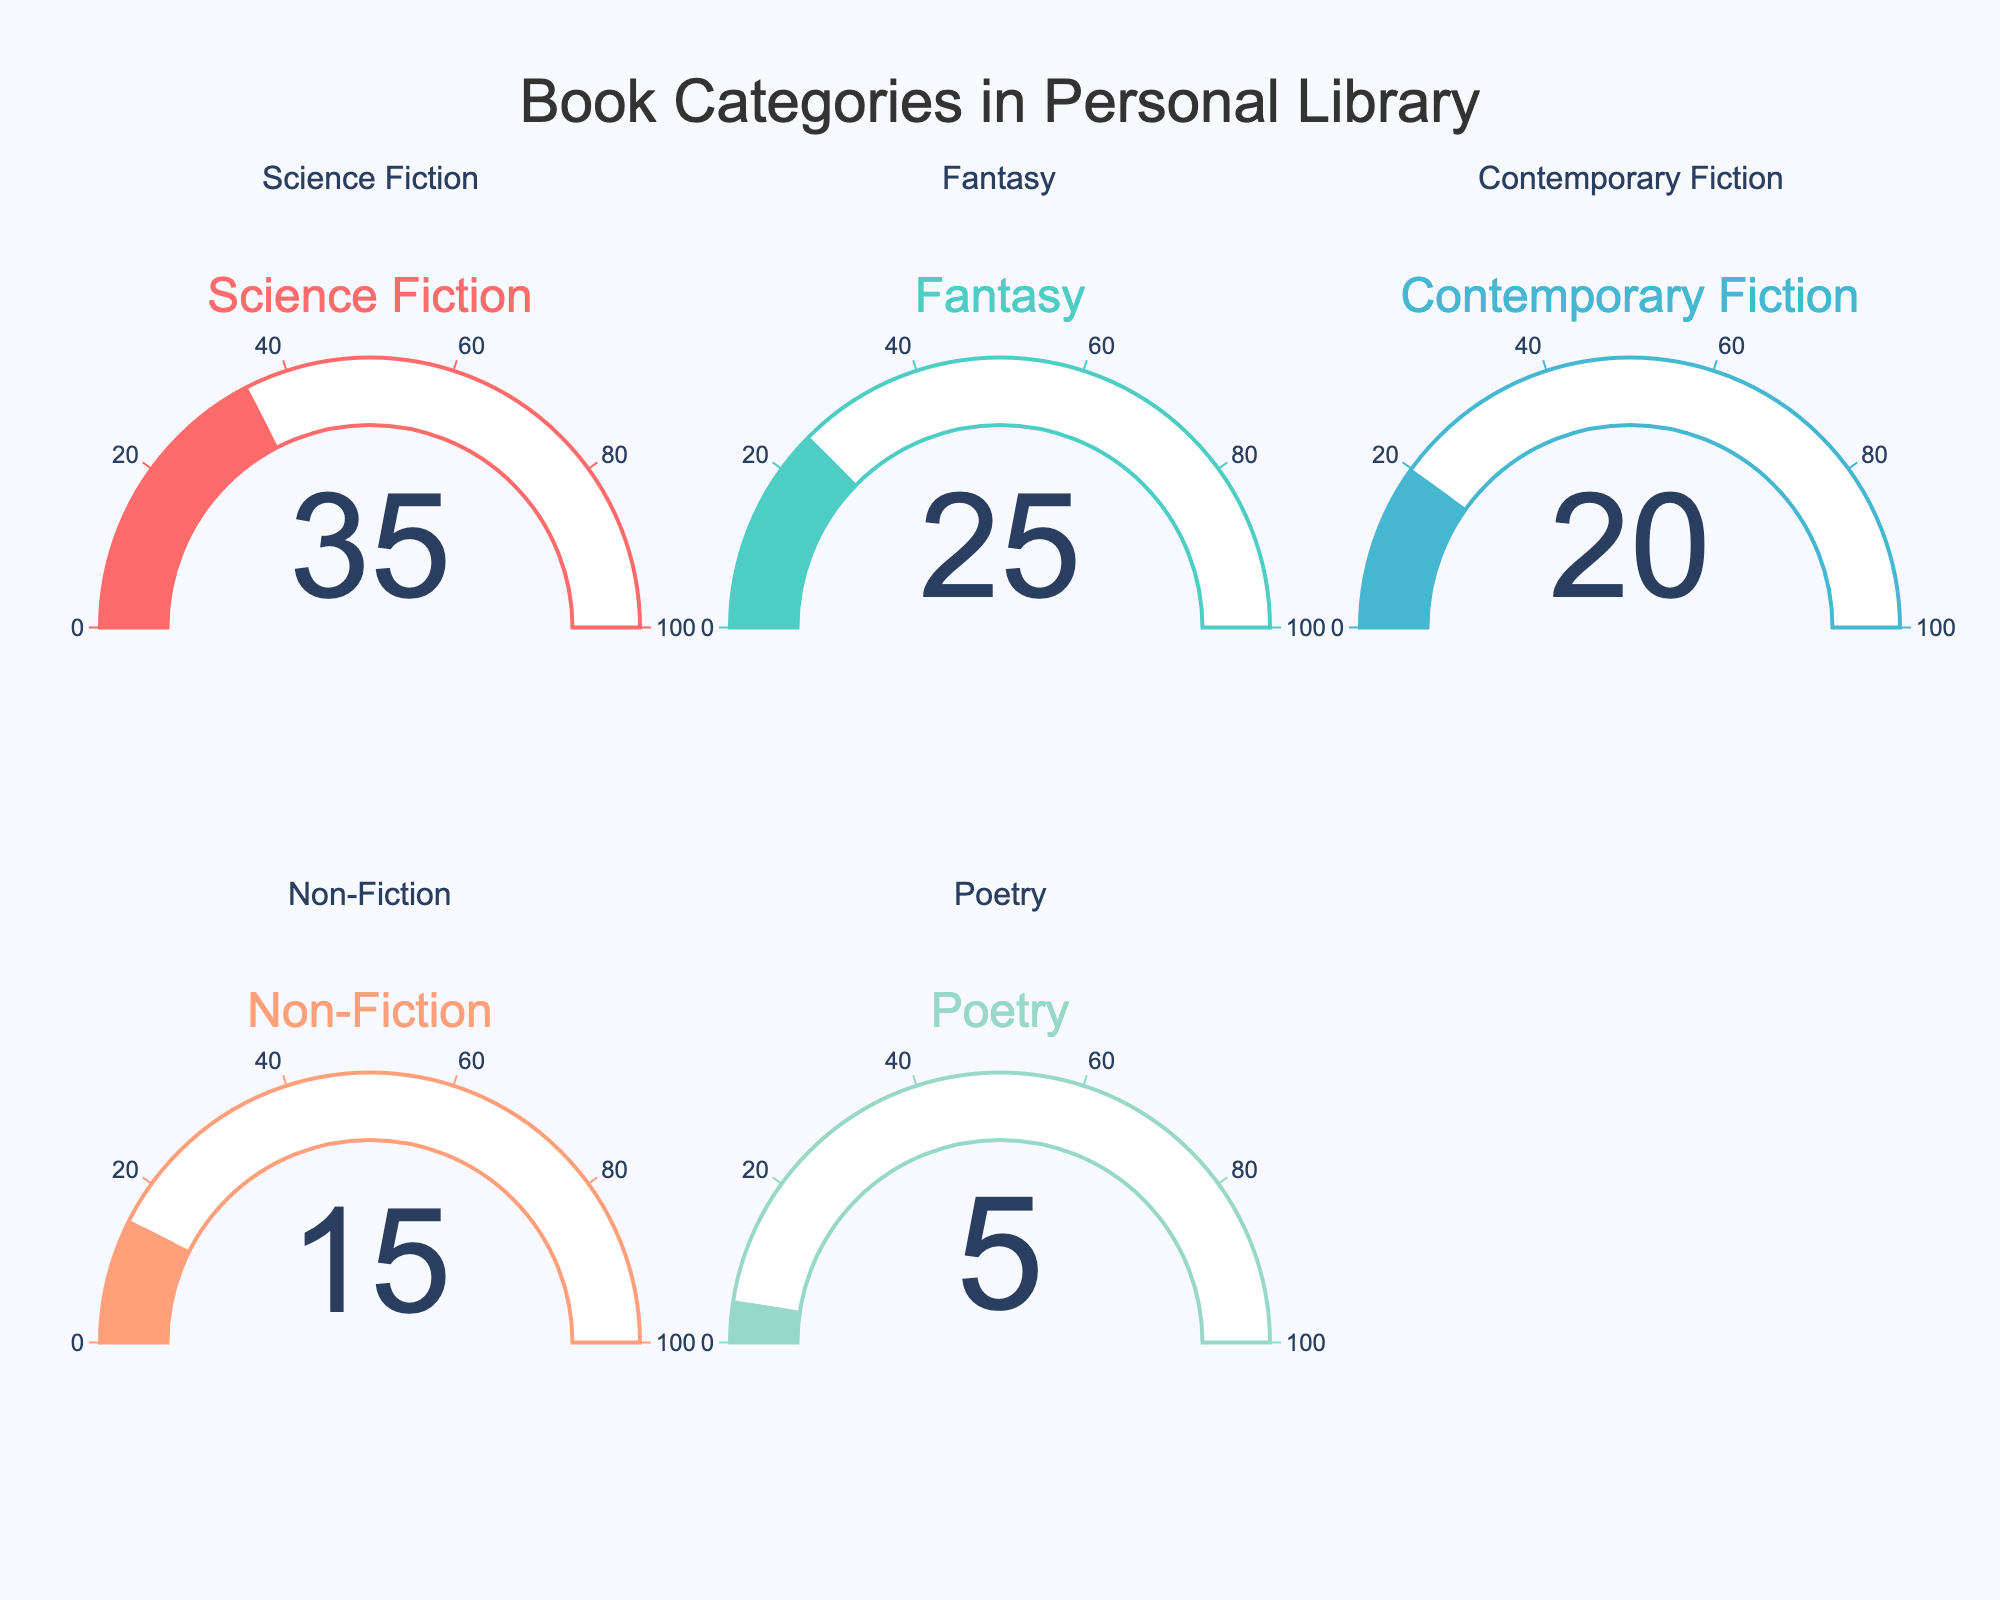What's the percentage of science fiction books in the personal library? The gauge for the "Science Fiction" category shows a value of 35%.
Answer: 35% Which category has the highest percentage of books in the personal library? By examining all the gauges, the highest value is associated with the "Science Fiction" category, which is 35%.
Answer: Science Fiction How much more is the percentage of science fiction books compared to poetry books? The percentage of science fiction books is 35% and for poetry books is 5%. The difference is 35% - 5% = 30%.
Answer: 30% What is the total percentage of fiction books in the personal library (sum of science fiction, fantasy, and contemporary fiction percentages)? Add the percentages of science fiction (35%), fantasy (25%), and contemporary fiction (20%). The total is 35% + 25% + 20% = 80%.
Answer: 80% What is the ratio of non-fiction books to total books in the personal library? The percentage of non-fiction books is 15%. The total percentage of all books is 100%. The ratio is 15 / 100 = 0.15.
Answer: 0.15 Which categories have a percentage less than contemporary fiction books? The percentage for contemporary fiction is 20%. Both non-fiction (15%) and poetry (5%) have percentages less than 20%.
Answer: Non-Fiction, Poetry What is the average percentage of all book categories in the personal library? Sum all the percentages and divide by the number of categories: (35% + 25% + 20% + 15% + 5%) / 5 = 100% / 5 = 20%.
Answer: 20% Between fantasy and contemporary fiction, which category has a greater percentage of books in the personal library? The gauge for fantasy shows 25%, while contemporary fiction shows 20%. So, fantasy has a greater percentage.
Answer: Fantasy What is the combined percentage of non-fiction and poetry books in the personal library? The percentage for non-fiction is 15% and for poetry is 5%. Their combined percentage is 15% + 5% = 20%.
Answer: 20% If the number of science fiction books were to increase by 5%, what would the new percentage be? Currently, the percentage of science fiction books is 35%. Adding 5% would make it 35% + 5% = 40%.
Answer: 40% 